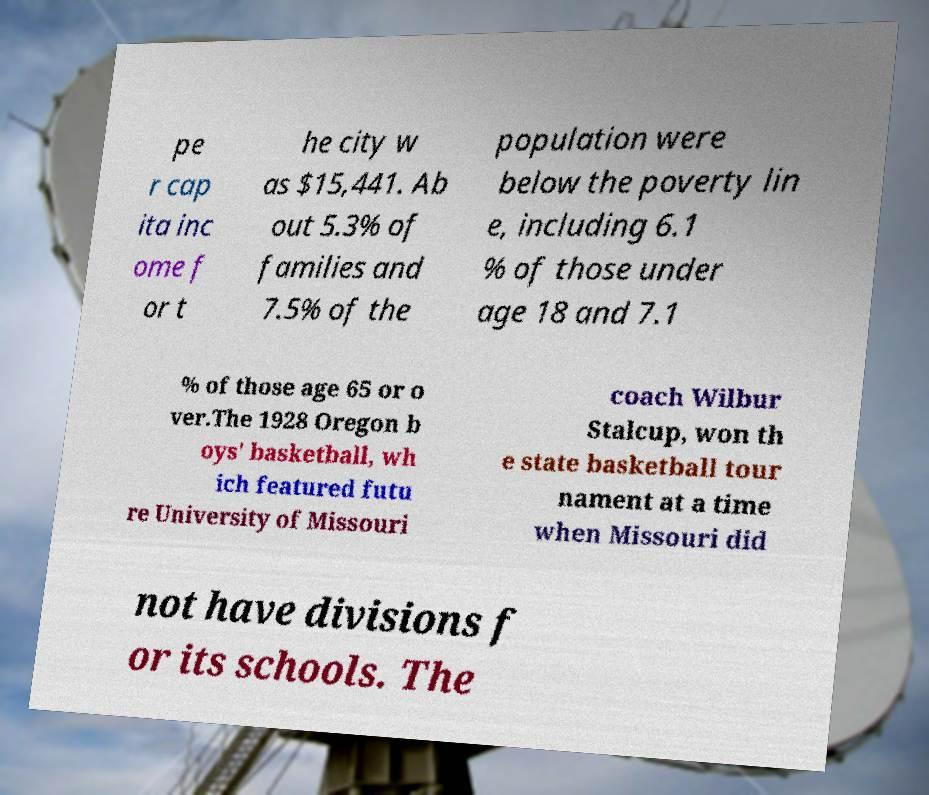I need the written content from this picture converted into text. Can you do that? pe r cap ita inc ome f or t he city w as $15,441. Ab out 5.3% of families and 7.5% of the population were below the poverty lin e, including 6.1 % of those under age 18 and 7.1 % of those age 65 or o ver.The 1928 Oregon b oys' basketball, wh ich featured futu re University of Missouri coach Wilbur Stalcup, won th e state basketball tour nament at a time when Missouri did not have divisions f or its schools. The 